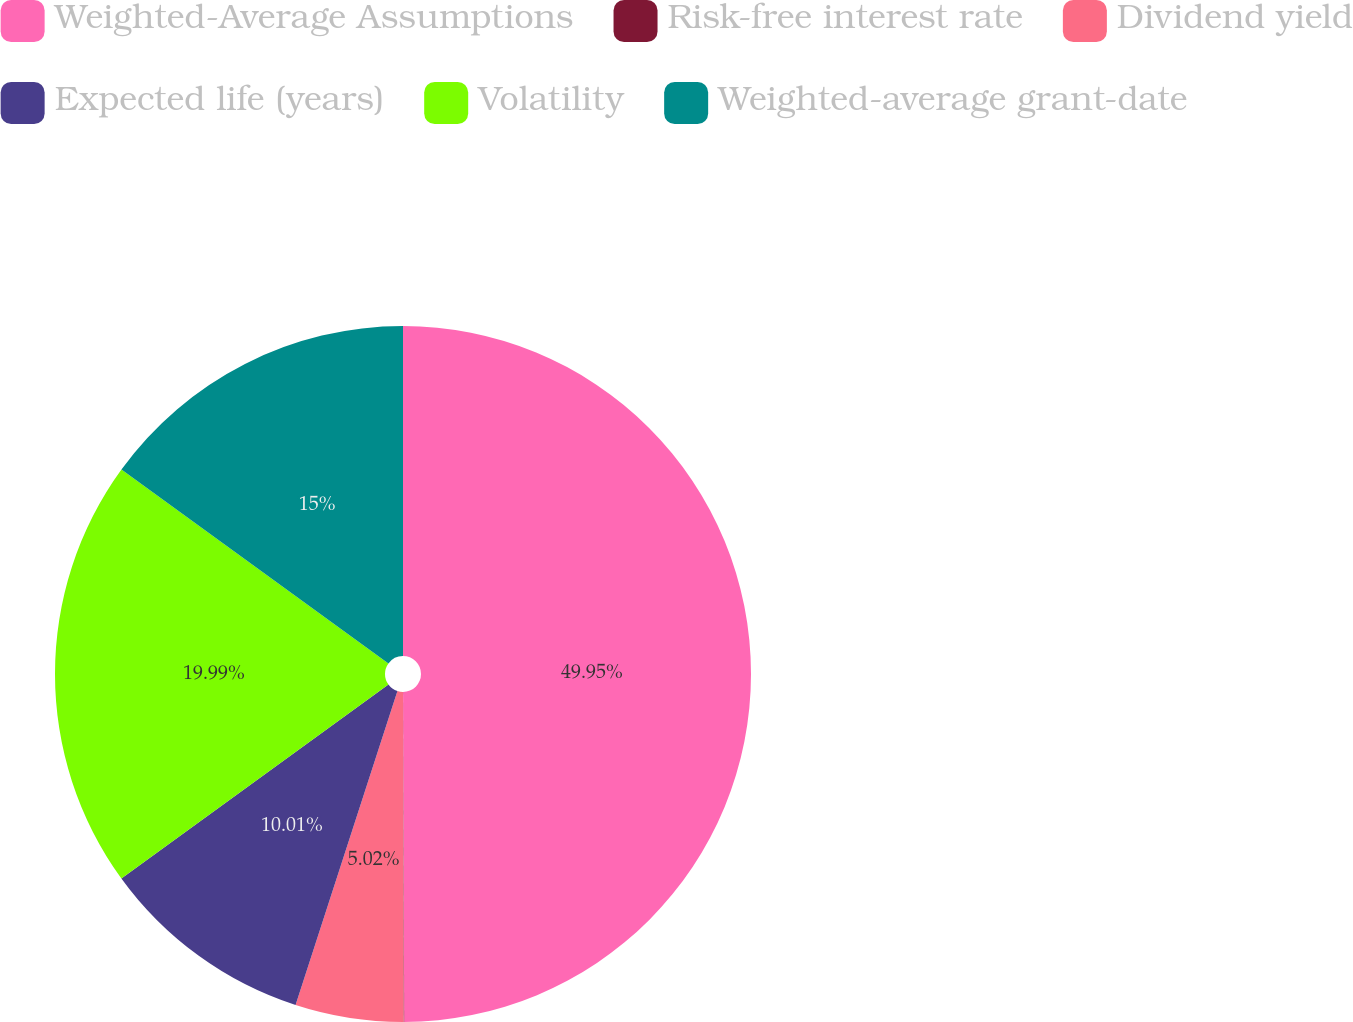Convert chart. <chart><loc_0><loc_0><loc_500><loc_500><pie_chart><fcel>Weighted-Average Assumptions<fcel>Risk-free interest rate<fcel>Dividend yield<fcel>Expected life (years)<fcel>Volatility<fcel>Weighted-average grant-date<nl><fcel>49.94%<fcel>0.03%<fcel>5.02%<fcel>10.01%<fcel>19.99%<fcel>15.0%<nl></chart> 